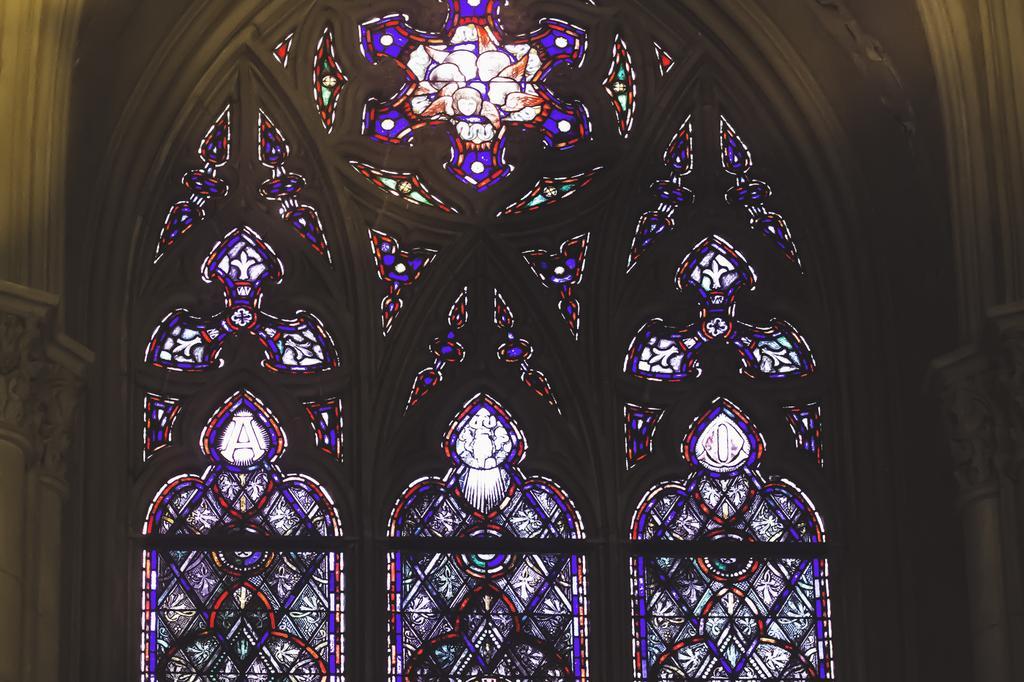Could you give a brief overview of what you see in this image? In this image I can see a glass windows and paintings on it. 